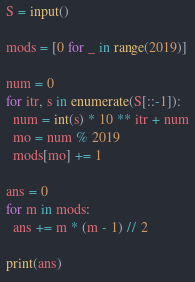Convert code to text. <code><loc_0><loc_0><loc_500><loc_500><_Python_>S = input()

mods = [0 for _ in range(2019)]

num = 0
for itr, s in enumerate(S[::-1]):
  num = int(s) * 10 ** itr + num
  mo = num % 2019
  mods[mo] += 1

ans = 0
for m in mods:
  ans += m * (m - 1) // 2

print(ans)
</code> 